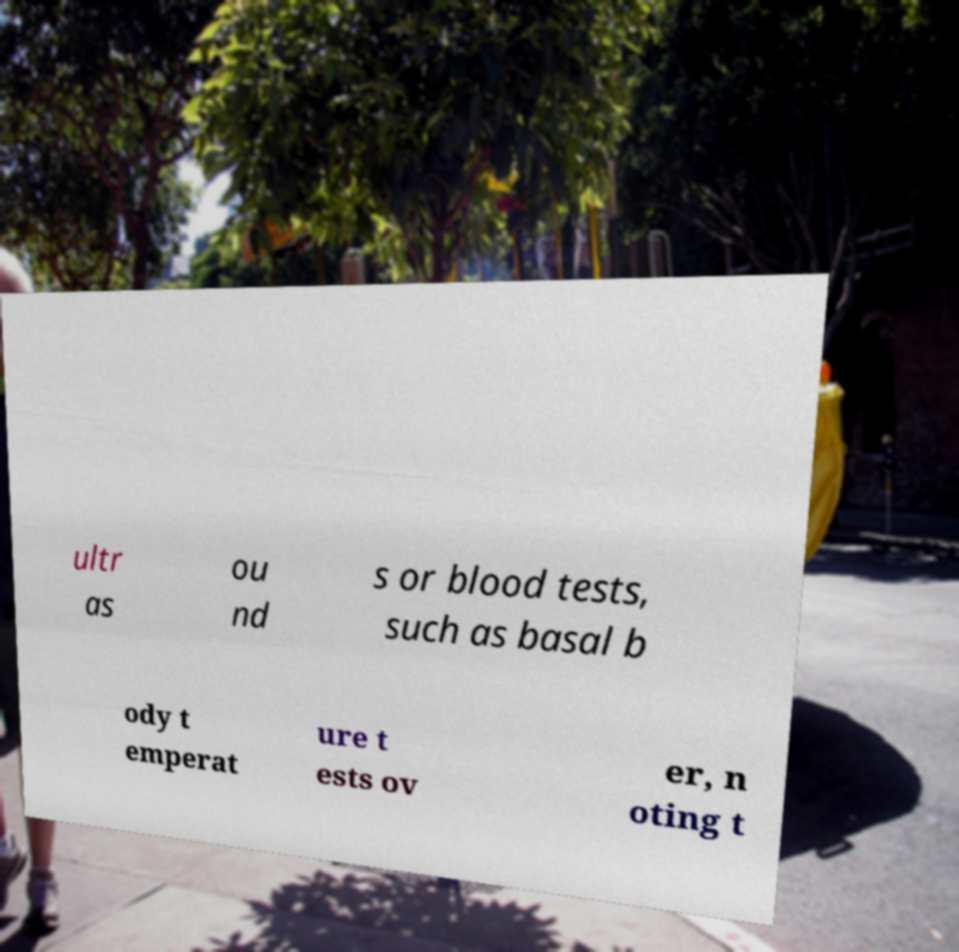Could you extract and type out the text from this image? ultr as ou nd s or blood tests, such as basal b ody t emperat ure t ests ov er, n oting t 